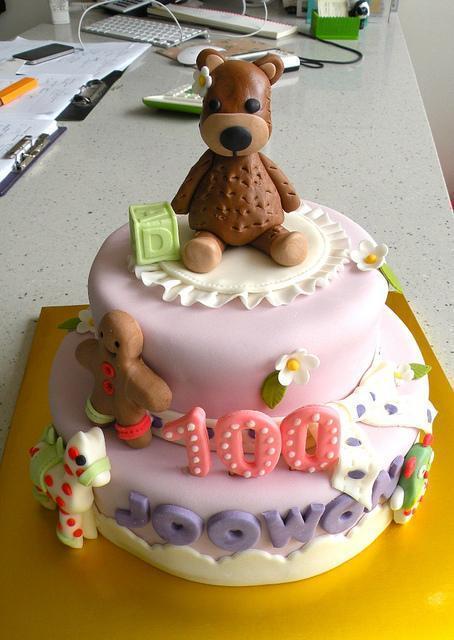How many people are in the picture?
Give a very brief answer. 0. 